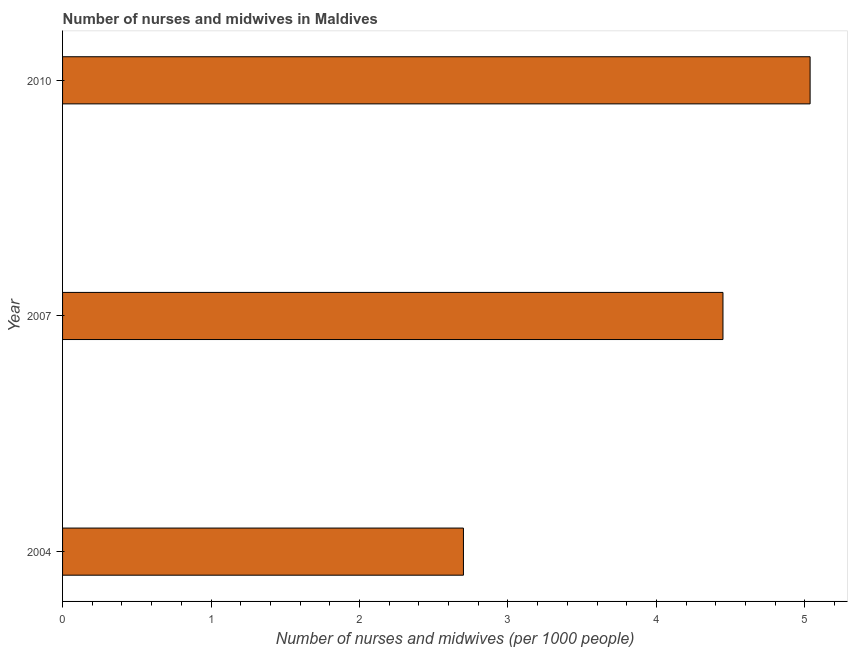Does the graph contain grids?
Provide a succinct answer. No. What is the title of the graph?
Offer a terse response. Number of nurses and midwives in Maldives. What is the label or title of the X-axis?
Offer a very short reply. Number of nurses and midwives (per 1000 people). What is the label or title of the Y-axis?
Your response must be concise. Year. What is the number of nurses and midwives in 2010?
Offer a very short reply. 5.04. Across all years, what is the maximum number of nurses and midwives?
Offer a terse response. 5.04. In which year was the number of nurses and midwives maximum?
Provide a succinct answer. 2010. In which year was the number of nurses and midwives minimum?
Provide a succinct answer. 2004. What is the sum of the number of nurses and midwives?
Offer a very short reply. 12.18. What is the difference between the number of nurses and midwives in 2004 and 2010?
Offer a terse response. -2.33. What is the average number of nurses and midwives per year?
Your answer should be very brief. 4.06. What is the median number of nurses and midwives?
Keep it short and to the point. 4.45. In how many years, is the number of nurses and midwives greater than 2.4 ?
Your response must be concise. 3. What is the ratio of the number of nurses and midwives in 2004 to that in 2007?
Provide a succinct answer. 0.61. Is the difference between the number of nurses and midwives in 2004 and 2010 greater than the difference between any two years?
Your response must be concise. Yes. What is the difference between the highest and the second highest number of nurses and midwives?
Provide a short and direct response. 0.59. Is the sum of the number of nurses and midwives in 2004 and 2007 greater than the maximum number of nurses and midwives across all years?
Offer a very short reply. Yes. What is the difference between the highest and the lowest number of nurses and midwives?
Give a very brief answer. 2.33. In how many years, is the number of nurses and midwives greater than the average number of nurses and midwives taken over all years?
Offer a terse response. 2. How many bars are there?
Make the answer very short. 3. What is the difference between two consecutive major ticks on the X-axis?
Keep it short and to the point. 1. What is the Number of nurses and midwives (per 1000 people) in 2004?
Provide a short and direct response. 2.7. What is the Number of nurses and midwives (per 1000 people) in 2007?
Make the answer very short. 4.45. What is the Number of nurses and midwives (per 1000 people) of 2010?
Your answer should be compact. 5.04. What is the difference between the Number of nurses and midwives (per 1000 people) in 2004 and 2007?
Make the answer very short. -1.75. What is the difference between the Number of nurses and midwives (per 1000 people) in 2004 and 2010?
Your response must be concise. -2.33. What is the difference between the Number of nurses and midwives (per 1000 people) in 2007 and 2010?
Ensure brevity in your answer.  -0.59. What is the ratio of the Number of nurses and midwives (per 1000 people) in 2004 to that in 2007?
Offer a very short reply. 0.61. What is the ratio of the Number of nurses and midwives (per 1000 people) in 2004 to that in 2010?
Your answer should be very brief. 0.54. What is the ratio of the Number of nurses and midwives (per 1000 people) in 2007 to that in 2010?
Keep it short and to the point. 0.88. 